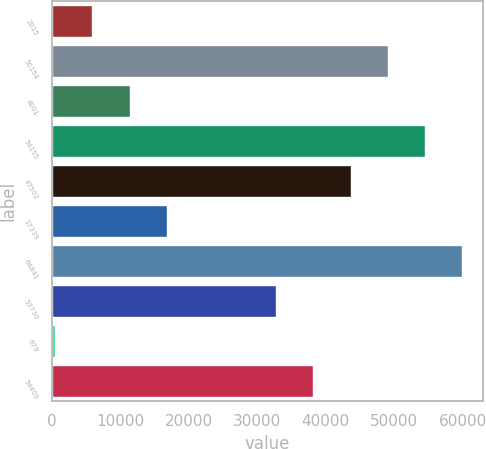Convert chart. <chart><loc_0><loc_0><loc_500><loc_500><bar_chart><fcel>2015<fcel>50154<fcel>4001<fcel>54155<fcel>47502<fcel>17339<fcel>64841<fcel>53730<fcel>679<fcel>54409<nl><fcel>5887.7<fcel>49052.1<fcel>11326.4<fcel>54490.8<fcel>43613.4<fcel>16765.1<fcel>59929.5<fcel>32736<fcel>449<fcel>38174.7<nl></chart> 